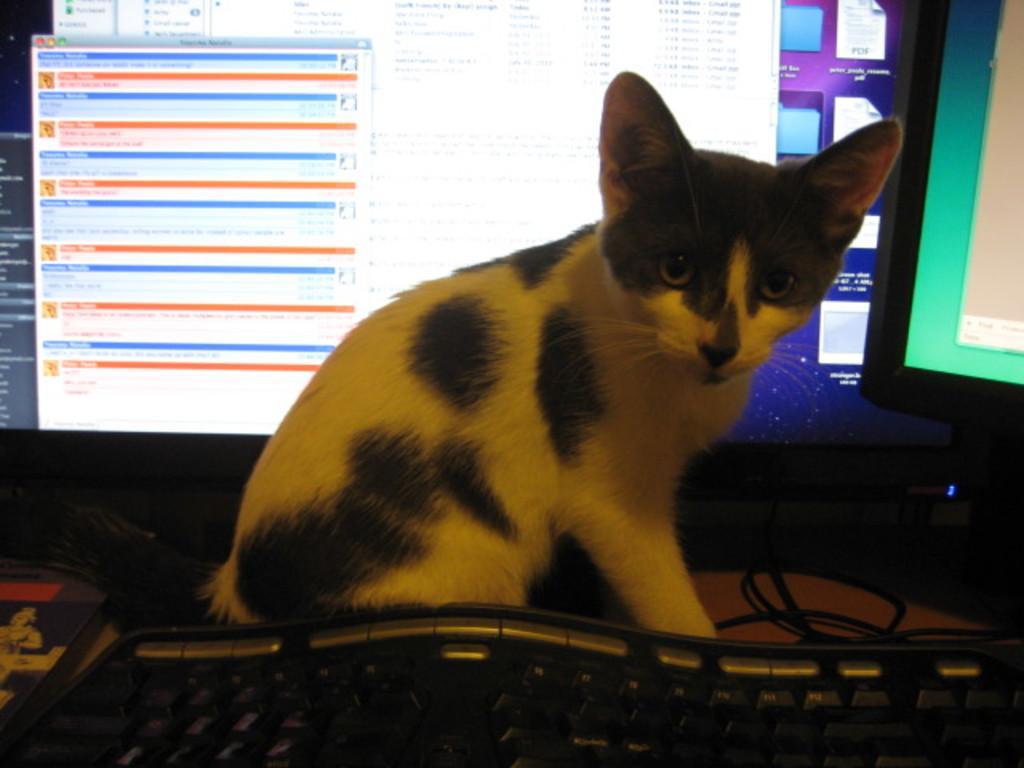In one or two sentences, can you explain what this image depicts? In this image, we can see a cat. We can see some screens, a keyboard and some wires. We can also see an object on the left. 